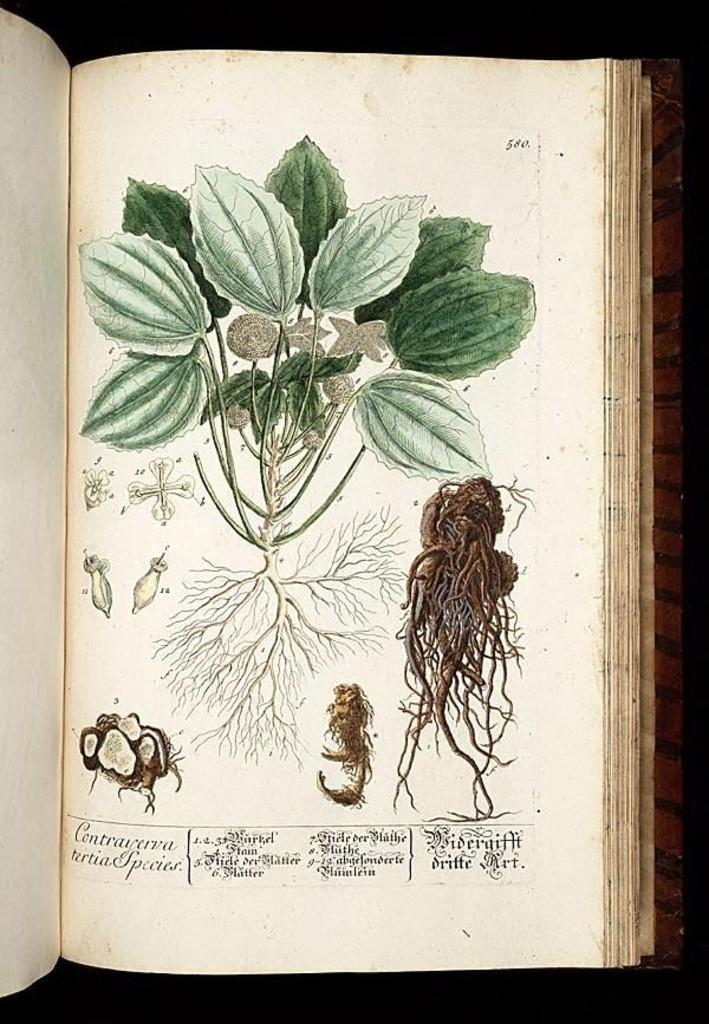What object related to reading or learning is present in the image? There is a book in the image. What type of living organism is present in the image? There is a plant in the image. Can you describe any unique features of the plant? There is text visible on the plant. What type of cup is visible on the plant in the image? There is no cup present on the plant in the image. What type of tax is being discussed in the text visible on the plant? There is no tax being discussed in the text visible on the plant; it is not related to taxation. 